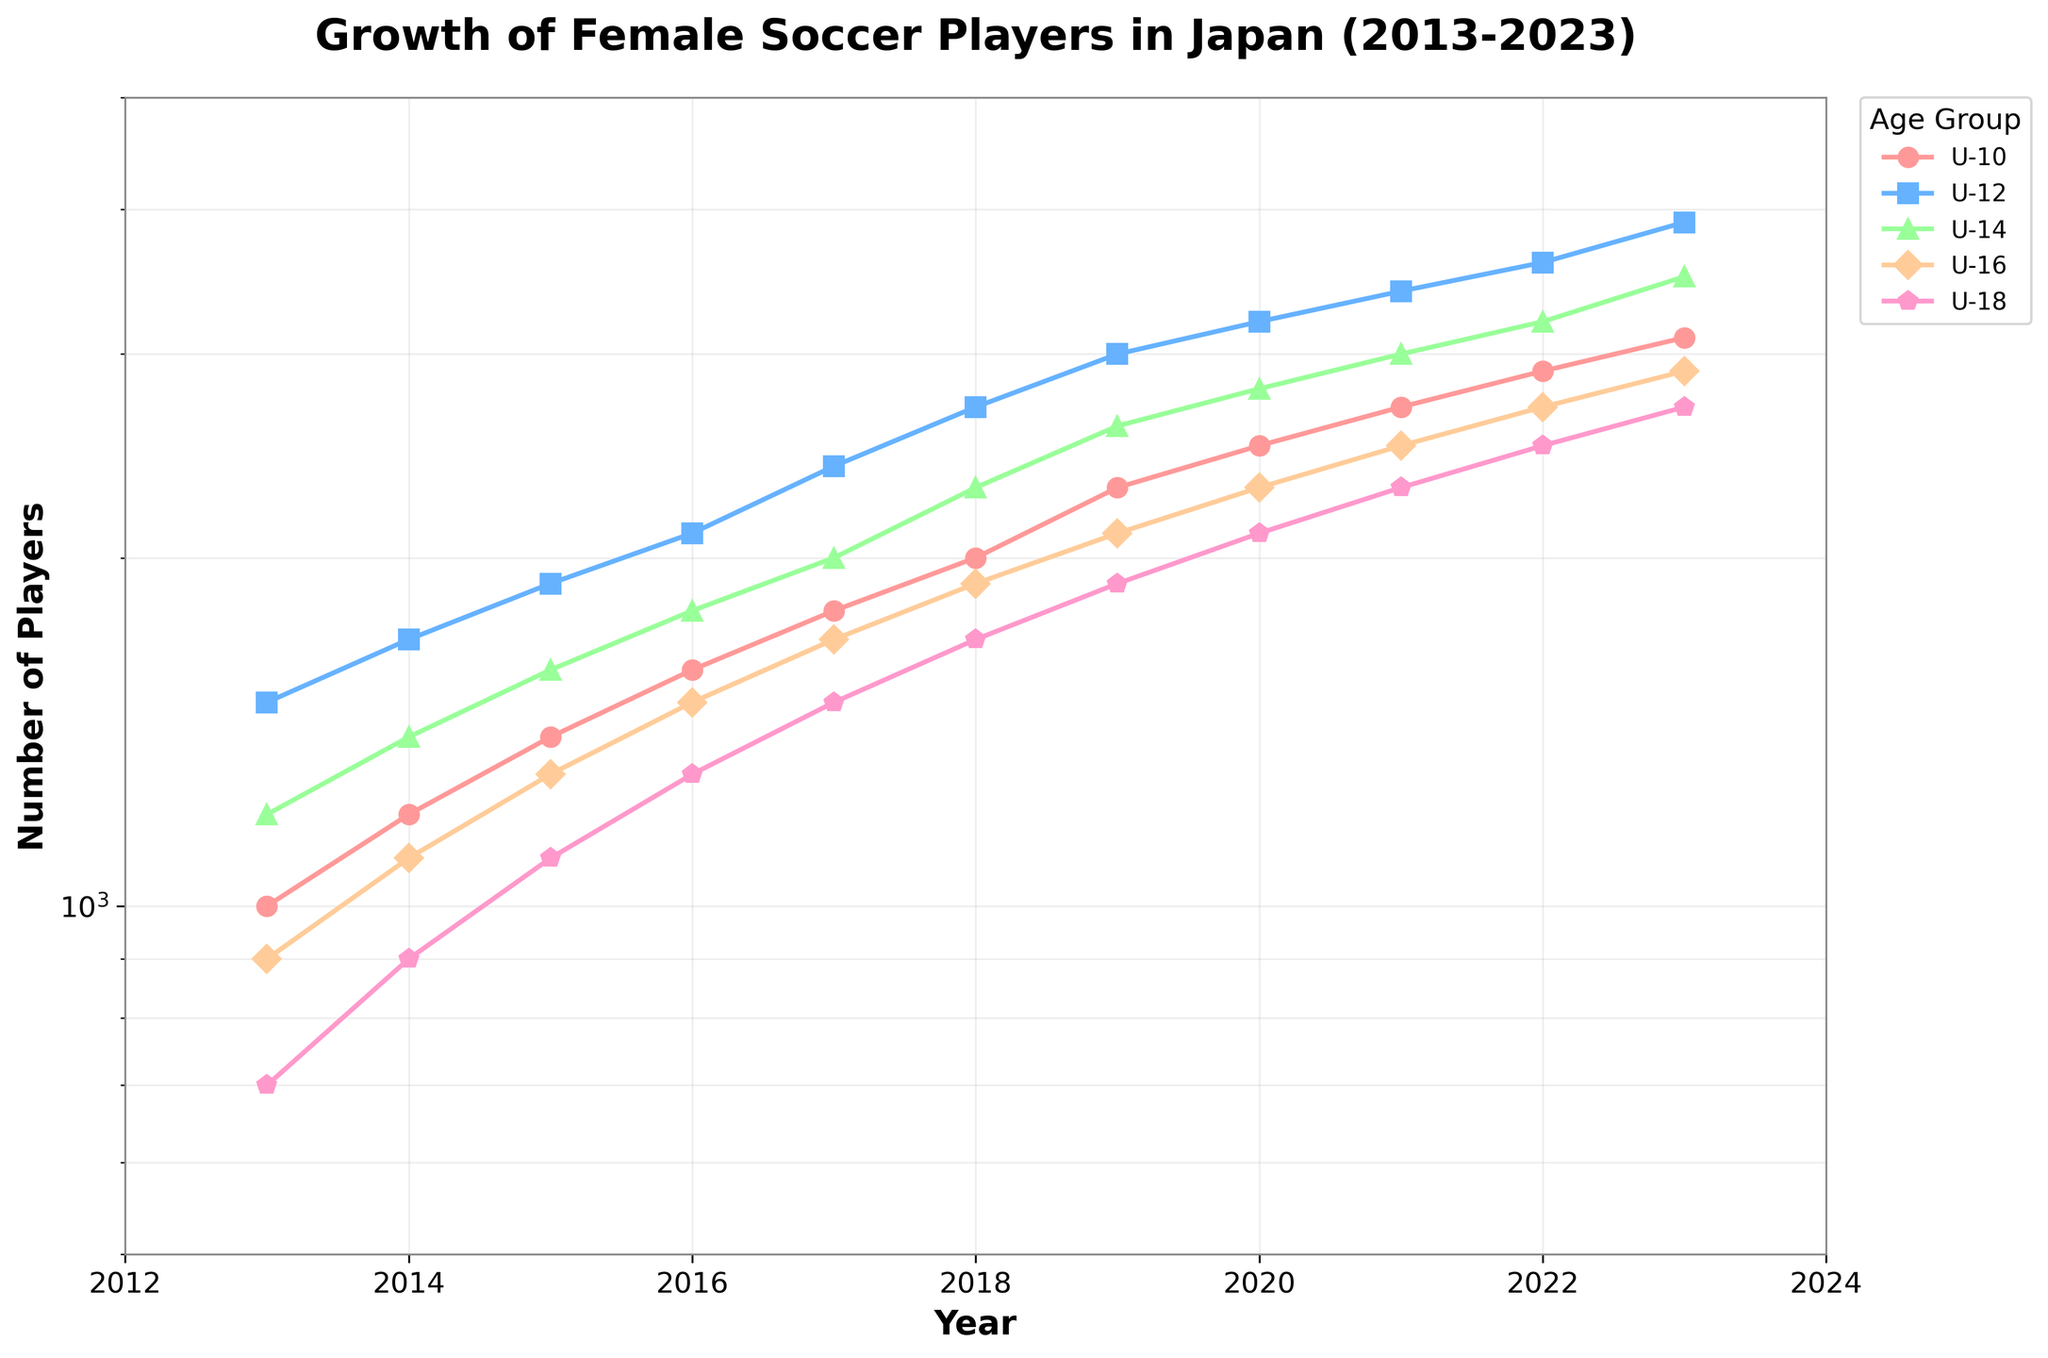What is the title of the figure? The title of the figure is located at the top and it provides an overview of the chart's content. The title reads "Growth of Female Soccer Players in Japan (2013-2023)"
Answer: Growth of Female Soccer Players in Japan (2013-2023) Which age group had the highest number of players in 2022? To find the age group with the highest number of players in 2022, look at the data points for each age group at the year 2022 on the x-axis. The highest point corresponds to the U-10 age group.
Answer: U-10 What is the overall trend for female soccer players' participation across all age groups? Looking at the plot, all age groups show an upward trend over the years, indicating growth in the number of female soccer players over the decade. This is indicated by the increasing data points for each age group from 2013 to 2023.
Answer: Increasing Between which years did the U-12 age group see the largest increase in player numbers? To determined the largest increase, compare the differences in player numbers between consecutive years for the U-12 age group. The biggest difference is between 2022 (3600) and 2023 (3900), resulting in an increase of 300 players.
Answer: 2022-2023 How does the rate of increase in the number of U-16 players between 2013 and 2023 compare to that of U-18 players? To compare the rate of increase, calculate the difference in the number of players from 2013 to 2023 for both age groups. U-16 increased from 900 to 2900 (2000 players), whereas U-18 increased from 700 to 2700 (2000 players). Both age groups have an equal increase of 2000 players.
Answer: Equal What is the color used for the U-12 age group line? The color used for each age group line is distinct. The U-12 line is represented by a blueish color.
Answer: Blueish Which age group had the least number of players in 2019? To find the age group with the least number of players in 2019, look at the data points for each age group at the year 2019. The U-18 age group has the lowest data point in that year.
Answer: U-18 Is there any instance where the number of players in a younger age group is less than an older age group? Analyze the plot to see if the number of players in a younger age group ever falls below that of an older age group. No such instances are observed, the number always increases with younger age groups having more players consistently over the years.
Answer: No What is the average number of U-14 players from 2013 to 2023? To calculate the average, sum the number of U-14 players from each year and divide by the number of years (11). The total is (1200 + 1400 + 1600 + 1800 + 2000 + 2300 + 2600 + 2800 + 3000 + 3200 + 3500) = 26400. Dividing by 11, the average is 2400.
Answer: 2400 